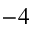Convert formula to latex. <formula><loc_0><loc_0><loc_500><loc_500>^ { - 4 }</formula> 